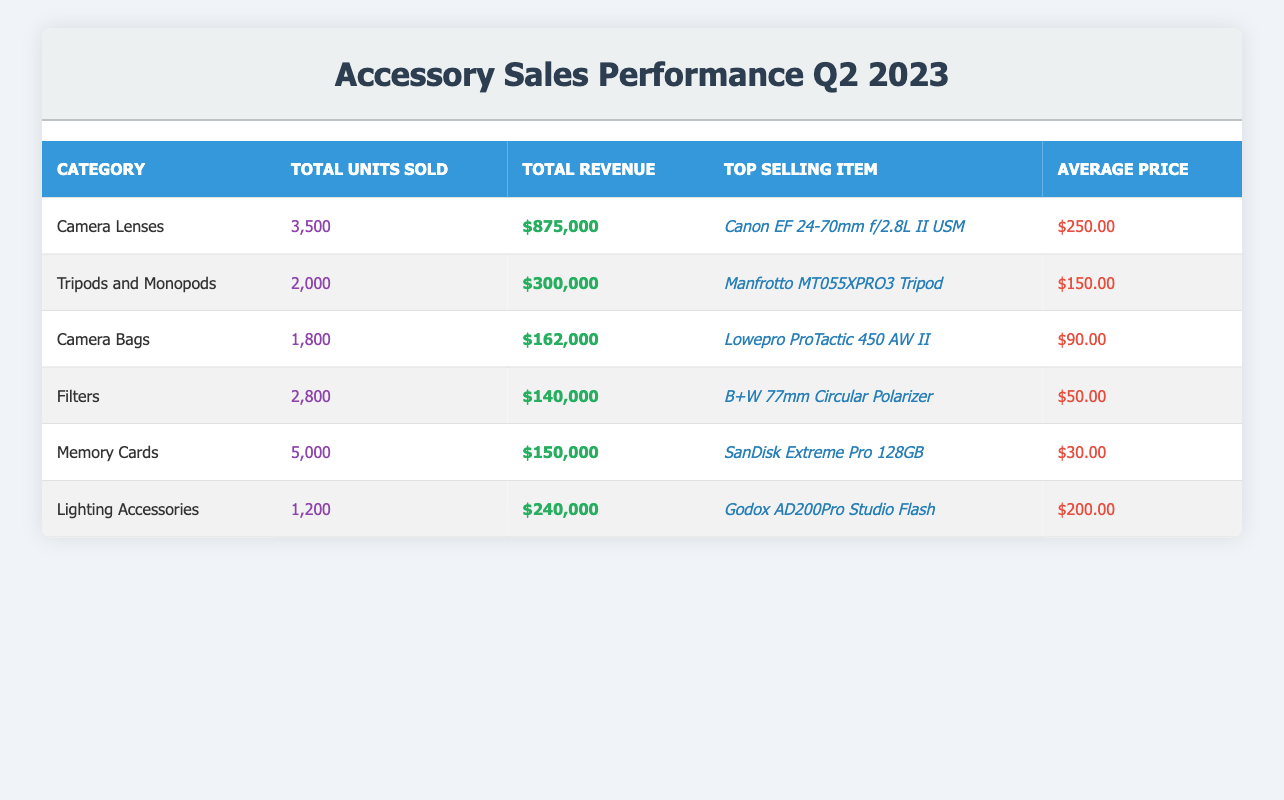What is the total revenue from Camera Lenses? The table states that the total revenue from Camera Lenses is provided directly under the "Total Revenue" column for that category, which reads $875,000.
Answer: $875,000 Which category sold the most units in Q2 2023? By comparing the "Total Units Sold" column across all categories, the highest value is 5,000 units sold under the category "Memory Cards."
Answer: Memory Cards What is the average price of the top-selling item in Camera Bags? Referring to the "Average Price" column, the average price of the top-selling item in the Camera Bags category is $90.00.
Answer: $90.00 How many more units were sold in Camera Lenses than in Lighting Accessories? The total units sold for Camera Lenses is 3,500, and for Lighting Accessories, it is 1,200. The difference is calculated as 3,500 - 1,200 = 2,300 units.
Answer: 2,300 Is the average price of Filters less than the average price of Camera Lenses? The average price of Filters is $50.00, and the average price of Camera Lenses is $250.00. Since $50.00 is less than $250.00, the statement is true.
Answer: Yes What is the total revenue generated by Tripods and Monopods and Lighting Accessories combined? To find the combined total revenue, we sum the values from both categories: Tripods and Monopods ($300,000) + Lighting Accessories ($240,000) = $540,000.
Answer: $540,000 What percentage of total units sold were Memory Cards? The total units sold for all categories are 3,500 + 2,000 + 1,800 + 2,800 + 5,000 + 1,200 = 16,300. The percentage for Memory Cards is calculated as (5,000 / 16,300) * 100 ≈ 30.67%.
Answer: 30.67% Which accessory category had the highest average price? Comparing the "Average Price" across all categories, the highest average price is in Camera Lenses at $250.00.
Answer: Camera Lenses Are the total units sold for Filters greater than those for Memory Cards? The total units sold for Filters is 2,800, while for Memory Cards it is 5,000. Since 2,800 is not greater than 5,000, the statement is false.
Answer: No 